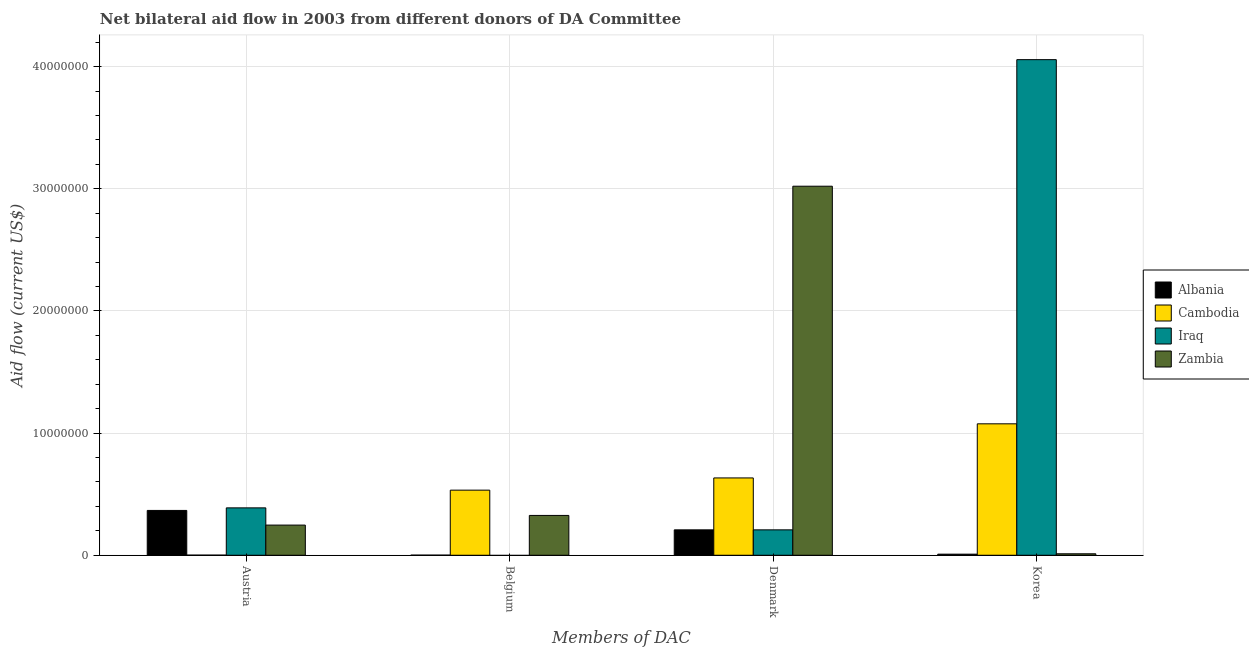Are the number of bars per tick equal to the number of legend labels?
Offer a very short reply. No. What is the label of the 2nd group of bars from the left?
Keep it short and to the point. Belgium. What is the amount of aid given by austria in Cambodia?
Your answer should be compact. 10000. Across all countries, what is the maximum amount of aid given by korea?
Make the answer very short. 4.06e+07. Across all countries, what is the minimum amount of aid given by austria?
Make the answer very short. 10000. In which country was the amount of aid given by denmark maximum?
Offer a terse response. Zambia. What is the total amount of aid given by austria in the graph?
Your answer should be very brief. 1.00e+07. What is the difference between the amount of aid given by austria in Cambodia and that in Iraq?
Ensure brevity in your answer.  -3.87e+06. What is the difference between the amount of aid given by belgium in Zambia and the amount of aid given by denmark in Iraq?
Offer a very short reply. 1.18e+06. What is the average amount of aid given by austria per country?
Your answer should be very brief. 2.51e+06. What is the difference between the amount of aid given by austria and amount of aid given by belgium in Zambia?
Offer a terse response. -7.90e+05. What is the ratio of the amount of aid given by korea in Albania to that in Zambia?
Ensure brevity in your answer.  0.75. Is the amount of aid given by austria in Cambodia less than that in Albania?
Offer a terse response. Yes. Is the difference between the amount of aid given by korea in Zambia and Cambodia greater than the difference between the amount of aid given by belgium in Zambia and Cambodia?
Your answer should be very brief. No. What is the difference between the highest and the second highest amount of aid given by korea?
Your response must be concise. 2.98e+07. What is the difference between the highest and the lowest amount of aid given by austria?
Your response must be concise. 3.87e+06. In how many countries, is the amount of aid given by denmark greater than the average amount of aid given by denmark taken over all countries?
Your answer should be very brief. 1. Is the sum of the amount of aid given by denmark in Zambia and Albania greater than the maximum amount of aid given by korea across all countries?
Provide a succinct answer. No. How many bars are there?
Make the answer very short. 15. Does the graph contain grids?
Provide a short and direct response. Yes. Where does the legend appear in the graph?
Give a very brief answer. Center right. What is the title of the graph?
Offer a very short reply. Net bilateral aid flow in 2003 from different donors of DA Committee. What is the label or title of the X-axis?
Your answer should be compact. Members of DAC. What is the Aid flow (current US$) of Albania in Austria?
Ensure brevity in your answer.  3.67e+06. What is the Aid flow (current US$) in Iraq in Austria?
Offer a terse response. 3.88e+06. What is the Aid flow (current US$) of Zambia in Austria?
Give a very brief answer. 2.47e+06. What is the Aid flow (current US$) of Cambodia in Belgium?
Your response must be concise. 5.33e+06. What is the Aid flow (current US$) in Zambia in Belgium?
Provide a short and direct response. 3.26e+06. What is the Aid flow (current US$) in Albania in Denmark?
Provide a short and direct response. 2.08e+06. What is the Aid flow (current US$) of Cambodia in Denmark?
Your answer should be compact. 6.33e+06. What is the Aid flow (current US$) of Iraq in Denmark?
Provide a short and direct response. 2.08e+06. What is the Aid flow (current US$) of Zambia in Denmark?
Make the answer very short. 3.02e+07. What is the Aid flow (current US$) in Cambodia in Korea?
Offer a terse response. 1.08e+07. What is the Aid flow (current US$) of Iraq in Korea?
Keep it short and to the point. 4.06e+07. Across all Members of DAC, what is the maximum Aid flow (current US$) of Albania?
Make the answer very short. 3.67e+06. Across all Members of DAC, what is the maximum Aid flow (current US$) in Cambodia?
Offer a very short reply. 1.08e+07. Across all Members of DAC, what is the maximum Aid flow (current US$) in Iraq?
Ensure brevity in your answer.  4.06e+07. Across all Members of DAC, what is the maximum Aid flow (current US$) in Zambia?
Your answer should be compact. 3.02e+07. Across all Members of DAC, what is the minimum Aid flow (current US$) in Cambodia?
Your response must be concise. 10000. What is the total Aid flow (current US$) in Albania in the graph?
Your answer should be very brief. 5.85e+06. What is the total Aid flow (current US$) in Cambodia in the graph?
Offer a terse response. 2.24e+07. What is the total Aid flow (current US$) of Iraq in the graph?
Ensure brevity in your answer.  4.65e+07. What is the total Aid flow (current US$) in Zambia in the graph?
Ensure brevity in your answer.  3.61e+07. What is the difference between the Aid flow (current US$) in Albania in Austria and that in Belgium?
Offer a very short reply. 3.66e+06. What is the difference between the Aid flow (current US$) of Cambodia in Austria and that in Belgium?
Ensure brevity in your answer.  -5.32e+06. What is the difference between the Aid flow (current US$) in Zambia in Austria and that in Belgium?
Keep it short and to the point. -7.90e+05. What is the difference between the Aid flow (current US$) of Albania in Austria and that in Denmark?
Provide a short and direct response. 1.59e+06. What is the difference between the Aid flow (current US$) of Cambodia in Austria and that in Denmark?
Your answer should be compact. -6.32e+06. What is the difference between the Aid flow (current US$) in Iraq in Austria and that in Denmark?
Provide a succinct answer. 1.80e+06. What is the difference between the Aid flow (current US$) in Zambia in Austria and that in Denmark?
Your response must be concise. -2.77e+07. What is the difference between the Aid flow (current US$) of Albania in Austria and that in Korea?
Provide a succinct answer. 3.58e+06. What is the difference between the Aid flow (current US$) in Cambodia in Austria and that in Korea?
Keep it short and to the point. -1.08e+07. What is the difference between the Aid flow (current US$) in Iraq in Austria and that in Korea?
Ensure brevity in your answer.  -3.67e+07. What is the difference between the Aid flow (current US$) of Zambia in Austria and that in Korea?
Keep it short and to the point. 2.35e+06. What is the difference between the Aid flow (current US$) of Albania in Belgium and that in Denmark?
Make the answer very short. -2.07e+06. What is the difference between the Aid flow (current US$) in Zambia in Belgium and that in Denmark?
Offer a terse response. -2.70e+07. What is the difference between the Aid flow (current US$) in Cambodia in Belgium and that in Korea?
Make the answer very short. -5.43e+06. What is the difference between the Aid flow (current US$) in Zambia in Belgium and that in Korea?
Give a very brief answer. 3.14e+06. What is the difference between the Aid flow (current US$) of Albania in Denmark and that in Korea?
Keep it short and to the point. 1.99e+06. What is the difference between the Aid flow (current US$) in Cambodia in Denmark and that in Korea?
Keep it short and to the point. -4.43e+06. What is the difference between the Aid flow (current US$) of Iraq in Denmark and that in Korea?
Give a very brief answer. -3.85e+07. What is the difference between the Aid flow (current US$) in Zambia in Denmark and that in Korea?
Provide a succinct answer. 3.01e+07. What is the difference between the Aid flow (current US$) of Albania in Austria and the Aid flow (current US$) of Cambodia in Belgium?
Offer a terse response. -1.66e+06. What is the difference between the Aid flow (current US$) in Albania in Austria and the Aid flow (current US$) in Zambia in Belgium?
Offer a very short reply. 4.10e+05. What is the difference between the Aid flow (current US$) in Cambodia in Austria and the Aid flow (current US$) in Zambia in Belgium?
Offer a very short reply. -3.25e+06. What is the difference between the Aid flow (current US$) in Iraq in Austria and the Aid flow (current US$) in Zambia in Belgium?
Offer a very short reply. 6.20e+05. What is the difference between the Aid flow (current US$) in Albania in Austria and the Aid flow (current US$) in Cambodia in Denmark?
Make the answer very short. -2.66e+06. What is the difference between the Aid flow (current US$) of Albania in Austria and the Aid flow (current US$) of Iraq in Denmark?
Offer a terse response. 1.59e+06. What is the difference between the Aid flow (current US$) of Albania in Austria and the Aid flow (current US$) of Zambia in Denmark?
Your response must be concise. -2.65e+07. What is the difference between the Aid flow (current US$) in Cambodia in Austria and the Aid flow (current US$) in Iraq in Denmark?
Offer a terse response. -2.07e+06. What is the difference between the Aid flow (current US$) of Cambodia in Austria and the Aid flow (current US$) of Zambia in Denmark?
Offer a terse response. -3.02e+07. What is the difference between the Aid flow (current US$) in Iraq in Austria and the Aid flow (current US$) in Zambia in Denmark?
Keep it short and to the point. -2.63e+07. What is the difference between the Aid flow (current US$) in Albania in Austria and the Aid flow (current US$) in Cambodia in Korea?
Your response must be concise. -7.09e+06. What is the difference between the Aid flow (current US$) of Albania in Austria and the Aid flow (current US$) of Iraq in Korea?
Ensure brevity in your answer.  -3.69e+07. What is the difference between the Aid flow (current US$) of Albania in Austria and the Aid flow (current US$) of Zambia in Korea?
Provide a succinct answer. 3.55e+06. What is the difference between the Aid flow (current US$) in Cambodia in Austria and the Aid flow (current US$) in Iraq in Korea?
Your response must be concise. -4.06e+07. What is the difference between the Aid flow (current US$) of Iraq in Austria and the Aid flow (current US$) of Zambia in Korea?
Your answer should be compact. 3.76e+06. What is the difference between the Aid flow (current US$) in Albania in Belgium and the Aid flow (current US$) in Cambodia in Denmark?
Provide a succinct answer. -6.32e+06. What is the difference between the Aid flow (current US$) of Albania in Belgium and the Aid flow (current US$) of Iraq in Denmark?
Offer a very short reply. -2.07e+06. What is the difference between the Aid flow (current US$) of Albania in Belgium and the Aid flow (current US$) of Zambia in Denmark?
Give a very brief answer. -3.02e+07. What is the difference between the Aid flow (current US$) in Cambodia in Belgium and the Aid flow (current US$) in Iraq in Denmark?
Offer a very short reply. 3.25e+06. What is the difference between the Aid flow (current US$) of Cambodia in Belgium and the Aid flow (current US$) of Zambia in Denmark?
Keep it short and to the point. -2.49e+07. What is the difference between the Aid flow (current US$) of Albania in Belgium and the Aid flow (current US$) of Cambodia in Korea?
Your answer should be compact. -1.08e+07. What is the difference between the Aid flow (current US$) in Albania in Belgium and the Aid flow (current US$) in Iraq in Korea?
Keep it short and to the point. -4.06e+07. What is the difference between the Aid flow (current US$) of Cambodia in Belgium and the Aid flow (current US$) of Iraq in Korea?
Ensure brevity in your answer.  -3.52e+07. What is the difference between the Aid flow (current US$) in Cambodia in Belgium and the Aid flow (current US$) in Zambia in Korea?
Offer a very short reply. 5.21e+06. What is the difference between the Aid flow (current US$) of Albania in Denmark and the Aid flow (current US$) of Cambodia in Korea?
Give a very brief answer. -8.68e+06. What is the difference between the Aid flow (current US$) in Albania in Denmark and the Aid flow (current US$) in Iraq in Korea?
Your response must be concise. -3.85e+07. What is the difference between the Aid flow (current US$) of Albania in Denmark and the Aid flow (current US$) of Zambia in Korea?
Ensure brevity in your answer.  1.96e+06. What is the difference between the Aid flow (current US$) of Cambodia in Denmark and the Aid flow (current US$) of Iraq in Korea?
Provide a succinct answer. -3.42e+07. What is the difference between the Aid flow (current US$) of Cambodia in Denmark and the Aid flow (current US$) of Zambia in Korea?
Make the answer very short. 6.21e+06. What is the difference between the Aid flow (current US$) of Iraq in Denmark and the Aid flow (current US$) of Zambia in Korea?
Your answer should be very brief. 1.96e+06. What is the average Aid flow (current US$) in Albania per Members of DAC?
Your answer should be compact. 1.46e+06. What is the average Aid flow (current US$) of Cambodia per Members of DAC?
Offer a terse response. 5.61e+06. What is the average Aid flow (current US$) in Iraq per Members of DAC?
Your answer should be very brief. 1.16e+07. What is the average Aid flow (current US$) in Zambia per Members of DAC?
Provide a short and direct response. 9.02e+06. What is the difference between the Aid flow (current US$) in Albania and Aid flow (current US$) in Cambodia in Austria?
Make the answer very short. 3.66e+06. What is the difference between the Aid flow (current US$) in Albania and Aid flow (current US$) in Iraq in Austria?
Provide a short and direct response. -2.10e+05. What is the difference between the Aid flow (current US$) of Albania and Aid flow (current US$) of Zambia in Austria?
Provide a short and direct response. 1.20e+06. What is the difference between the Aid flow (current US$) of Cambodia and Aid flow (current US$) of Iraq in Austria?
Offer a very short reply. -3.87e+06. What is the difference between the Aid flow (current US$) of Cambodia and Aid flow (current US$) of Zambia in Austria?
Provide a succinct answer. -2.46e+06. What is the difference between the Aid flow (current US$) of Iraq and Aid flow (current US$) of Zambia in Austria?
Provide a succinct answer. 1.41e+06. What is the difference between the Aid flow (current US$) in Albania and Aid flow (current US$) in Cambodia in Belgium?
Your answer should be very brief. -5.32e+06. What is the difference between the Aid flow (current US$) of Albania and Aid flow (current US$) of Zambia in Belgium?
Keep it short and to the point. -3.25e+06. What is the difference between the Aid flow (current US$) of Cambodia and Aid flow (current US$) of Zambia in Belgium?
Ensure brevity in your answer.  2.07e+06. What is the difference between the Aid flow (current US$) of Albania and Aid flow (current US$) of Cambodia in Denmark?
Keep it short and to the point. -4.25e+06. What is the difference between the Aid flow (current US$) in Albania and Aid flow (current US$) in Iraq in Denmark?
Ensure brevity in your answer.  0. What is the difference between the Aid flow (current US$) in Albania and Aid flow (current US$) in Zambia in Denmark?
Your answer should be very brief. -2.81e+07. What is the difference between the Aid flow (current US$) of Cambodia and Aid flow (current US$) of Iraq in Denmark?
Provide a succinct answer. 4.25e+06. What is the difference between the Aid flow (current US$) in Cambodia and Aid flow (current US$) in Zambia in Denmark?
Offer a very short reply. -2.39e+07. What is the difference between the Aid flow (current US$) in Iraq and Aid flow (current US$) in Zambia in Denmark?
Give a very brief answer. -2.81e+07. What is the difference between the Aid flow (current US$) of Albania and Aid flow (current US$) of Cambodia in Korea?
Ensure brevity in your answer.  -1.07e+07. What is the difference between the Aid flow (current US$) in Albania and Aid flow (current US$) in Iraq in Korea?
Provide a short and direct response. -4.05e+07. What is the difference between the Aid flow (current US$) of Cambodia and Aid flow (current US$) of Iraq in Korea?
Provide a short and direct response. -2.98e+07. What is the difference between the Aid flow (current US$) in Cambodia and Aid flow (current US$) in Zambia in Korea?
Make the answer very short. 1.06e+07. What is the difference between the Aid flow (current US$) in Iraq and Aid flow (current US$) in Zambia in Korea?
Offer a very short reply. 4.04e+07. What is the ratio of the Aid flow (current US$) of Albania in Austria to that in Belgium?
Make the answer very short. 367. What is the ratio of the Aid flow (current US$) in Cambodia in Austria to that in Belgium?
Provide a short and direct response. 0. What is the ratio of the Aid flow (current US$) of Zambia in Austria to that in Belgium?
Offer a very short reply. 0.76. What is the ratio of the Aid flow (current US$) of Albania in Austria to that in Denmark?
Ensure brevity in your answer.  1.76. What is the ratio of the Aid flow (current US$) of Cambodia in Austria to that in Denmark?
Make the answer very short. 0. What is the ratio of the Aid flow (current US$) of Iraq in Austria to that in Denmark?
Your response must be concise. 1.87. What is the ratio of the Aid flow (current US$) in Zambia in Austria to that in Denmark?
Your answer should be compact. 0.08. What is the ratio of the Aid flow (current US$) in Albania in Austria to that in Korea?
Offer a very short reply. 40.78. What is the ratio of the Aid flow (current US$) of Cambodia in Austria to that in Korea?
Make the answer very short. 0. What is the ratio of the Aid flow (current US$) of Iraq in Austria to that in Korea?
Ensure brevity in your answer.  0.1. What is the ratio of the Aid flow (current US$) of Zambia in Austria to that in Korea?
Give a very brief answer. 20.58. What is the ratio of the Aid flow (current US$) of Albania in Belgium to that in Denmark?
Offer a very short reply. 0. What is the ratio of the Aid flow (current US$) of Cambodia in Belgium to that in Denmark?
Ensure brevity in your answer.  0.84. What is the ratio of the Aid flow (current US$) of Zambia in Belgium to that in Denmark?
Your answer should be compact. 0.11. What is the ratio of the Aid flow (current US$) in Albania in Belgium to that in Korea?
Ensure brevity in your answer.  0.11. What is the ratio of the Aid flow (current US$) of Cambodia in Belgium to that in Korea?
Offer a very short reply. 0.5. What is the ratio of the Aid flow (current US$) of Zambia in Belgium to that in Korea?
Offer a very short reply. 27.17. What is the ratio of the Aid flow (current US$) in Albania in Denmark to that in Korea?
Offer a terse response. 23.11. What is the ratio of the Aid flow (current US$) in Cambodia in Denmark to that in Korea?
Offer a very short reply. 0.59. What is the ratio of the Aid flow (current US$) of Iraq in Denmark to that in Korea?
Your response must be concise. 0.05. What is the ratio of the Aid flow (current US$) of Zambia in Denmark to that in Korea?
Provide a succinct answer. 251.75. What is the difference between the highest and the second highest Aid flow (current US$) of Albania?
Your answer should be compact. 1.59e+06. What is the difference between the highest and the second highest Aid flow (current US$) of Cambodia?
Offer a terse response. 4.43e+06. What is the difference between the highest and the second highest Aid flow (current US$) of Iraq?
Your response must be concise. 3.67e+07. What is the difference between the highest and the second highest Aid flow (current US$) in Zambia?
Ensure brevity in your answer.  2.70e+07. What is the difference between the highest and the lowest Aid flow (current US$) in Albania?
Make the answer very short. 3.66e+06. What is the difference between the highest and the lowest Aid flow (current US$) in Cambodia?
Ensure brevity in your answer.  1.08e+07. What is the difference between the highest and the lowest Aid flow (current US$) in Iraq?
Ensure brevity in your answer.  4.06e+07. What is the difference between the highest and the lowest Aid flow (current US$) of Zambia?
Your response must be concise. 3.01e+07. 